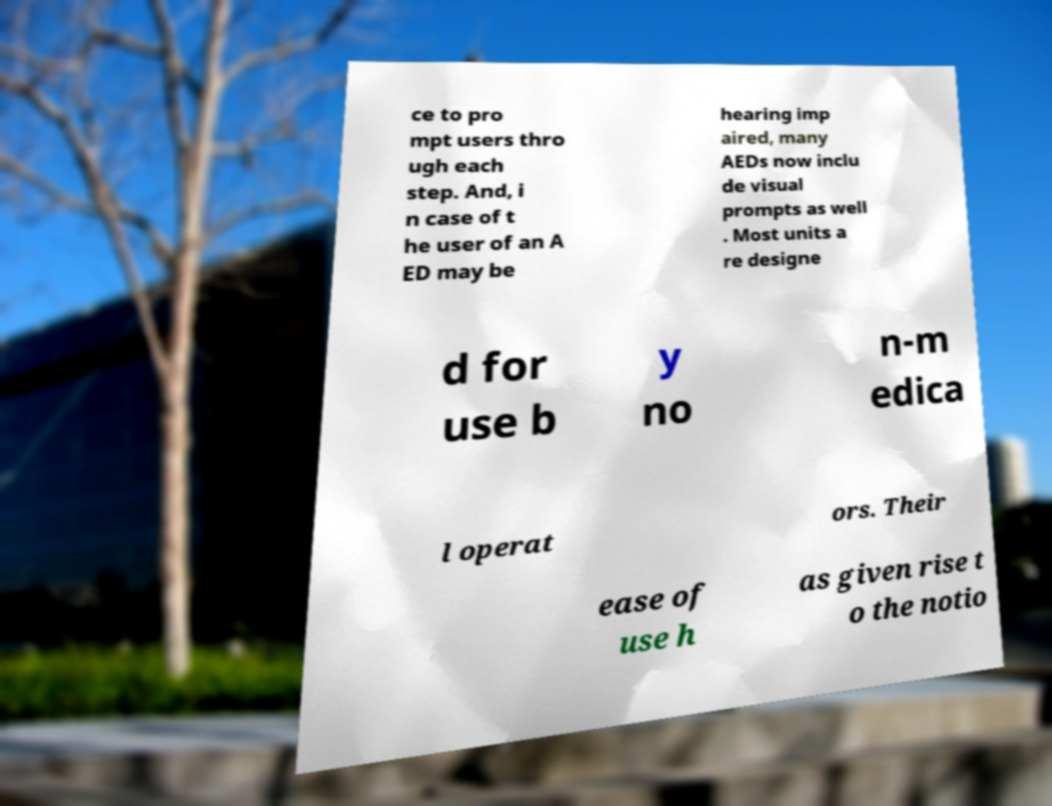Could you assist in decoding the text presented in this image and type it out clearly? ce to pro mpt users thro ugh each step. And, i n case of t he user of an A ED may be hearing imp aired, many AEDs now inclu de visual prompts as well . Most units a re designe d for use b y no n-m edica l operat ors. Their ease of use h as given rise t o the notio 